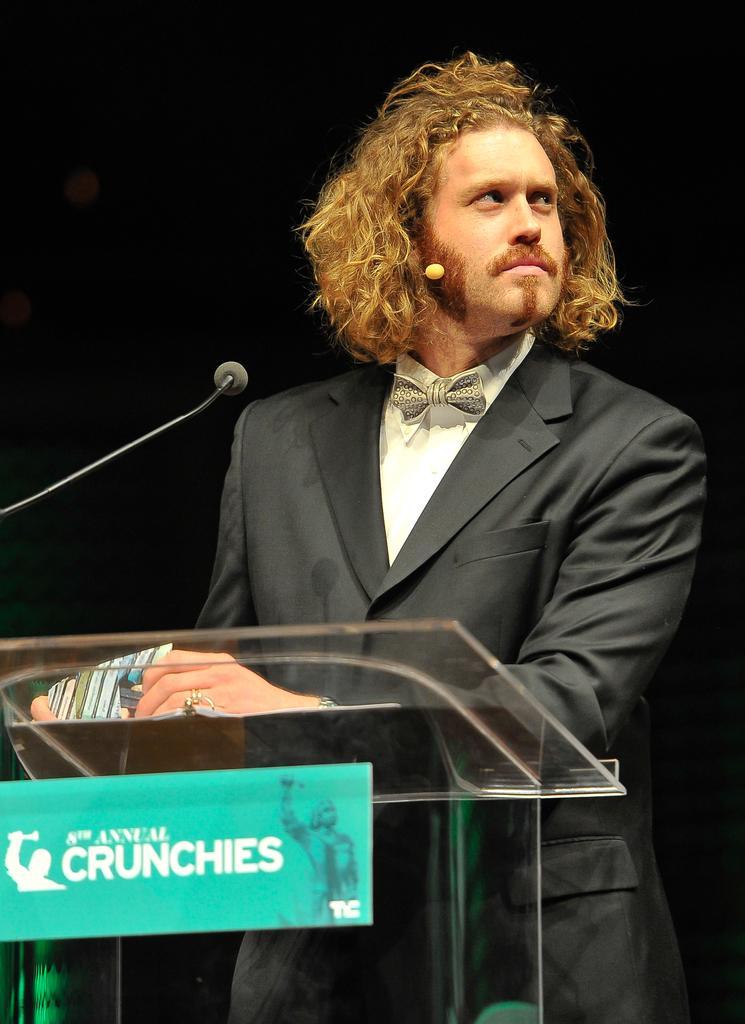Please provide a concise description of this image. In the picture I can see a person wearing blazer is standing near the podium where mc is placed on it. Here we can see green color board on which something is written is fixed to the podium. The background of the image is dark. 